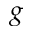Convert formula to latex. <formula><loc_0><loc_0><loc_500><loc_500>g</formula> 